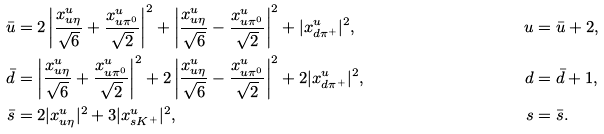Convert formula to latex. <formula><loc_0><loc_0><loc_500><loc_500>\bar { u } & = 2 \left | \frac { x ^ { u } _ { u \eta } } { \sqrt { 6 } } + \frac { x ^ { u } _ { u \pi ^ { 0 } } } { \sqrt { 2 } } \right | ^ { 2 } + \left | \frac { x ^ { u } _ { u \eta } } { \sqrt { 6 } } - \frac { x ^ { u } _ { u \pi ^ { 0 } } } { \sqrt { 2 } } \right | ^ { 2 } + | x ^ { u } _ { d \pi ^ { + } } | ^ { 2 } , & u & = \bar { u } + 2 , \\ \bar { d } & = \left | \frac { x ^ { u } _ { u \eta } } { \sqrt { 6 } } + \frac { x ^ { u } _ { u \pi ^ { 0 } } } { \sqrt { 2 } } \right | ^ { 2 } + 2 \left | \frac { x ^ { u } _ { u \eta } } { \sqrt { 6 } } - \frac { x ^ { u } _ { u \pi ^ { 0 } } } { \sqrt { 2 } } \right | ^ { 2 } + 2 | x ^ { u } _ { d \pi ^ { + } } | ^ { 2 } , & d & = \bar { d } + 1 , \\ \bar { s } & = 2 | x ^ { u } _ { u \eta } | ^ { 2 } + 3 | x ^ { u } _ { s K ^ { + } } | ^ { 2 } , & s & = \bar { s } .</formula> 